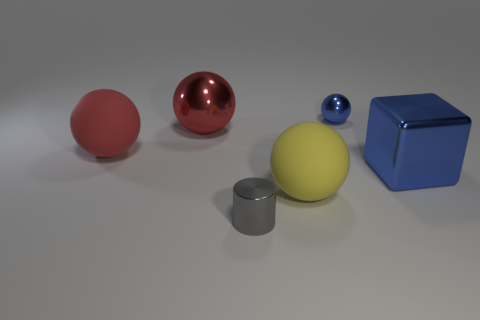Do the tiny metallic cylinder and the big matte object that is to the left of the cylinder have the same color?
Your answer should be very brief. No. Are there fewer metal cylinders that are in front of the blue cube than large blue objects that are to the left of the large yellow object?
Your answer should be compact. No. What is the color of the large sphere that is both in front of the red shiny object and left of the gray object?
Provide a short and direct response. Red. There is a red metallic sphere; does it have the same size as the blue thing on the right side of the blue sphere?
Offer a terse response. Yes. There is a object that is on the right side of the blue metallic sphere; what shape is it?
Offer a very short reply. Cube. Is there anything else that has the same material as the tiny gray cylinder?
Your answer should be compact. Yes. Is the number of big red things to the left of the big red metallic thing greater than the number of large things?
Offer a very short reply. No. What number of red metal things are on the right side of the metal ball that is in front of the tiny metallic object on the right side of the gray cylinder?
Give a very brief answer. 0. Does the metal object that is to the right of the tiny blue object have the same size as the metallic sphere to the right of the big metal ball?
Your answer should be very brief. No. What is the material of the big object that is right of the yellow ball that is to the right of the gray metallic cylinder?
Your answer should be compact. Metal. 